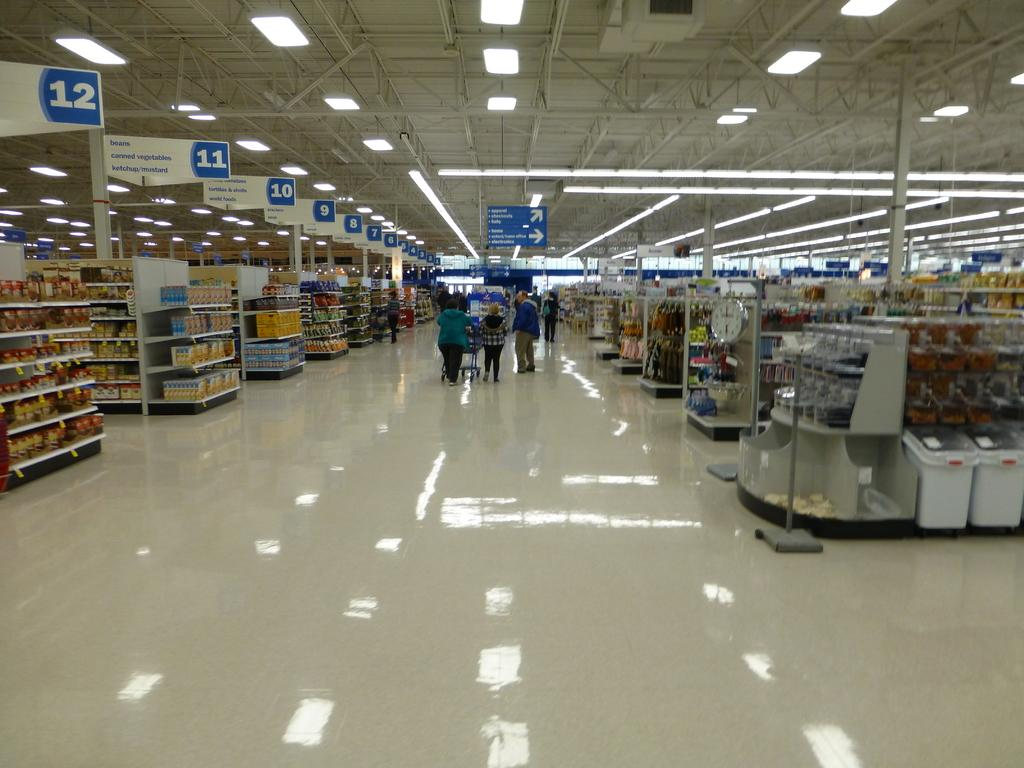<image>
Give a short and clear explanation of the subsequent image. Grocery store with people shopping near aisles 10, 11, and 12. 